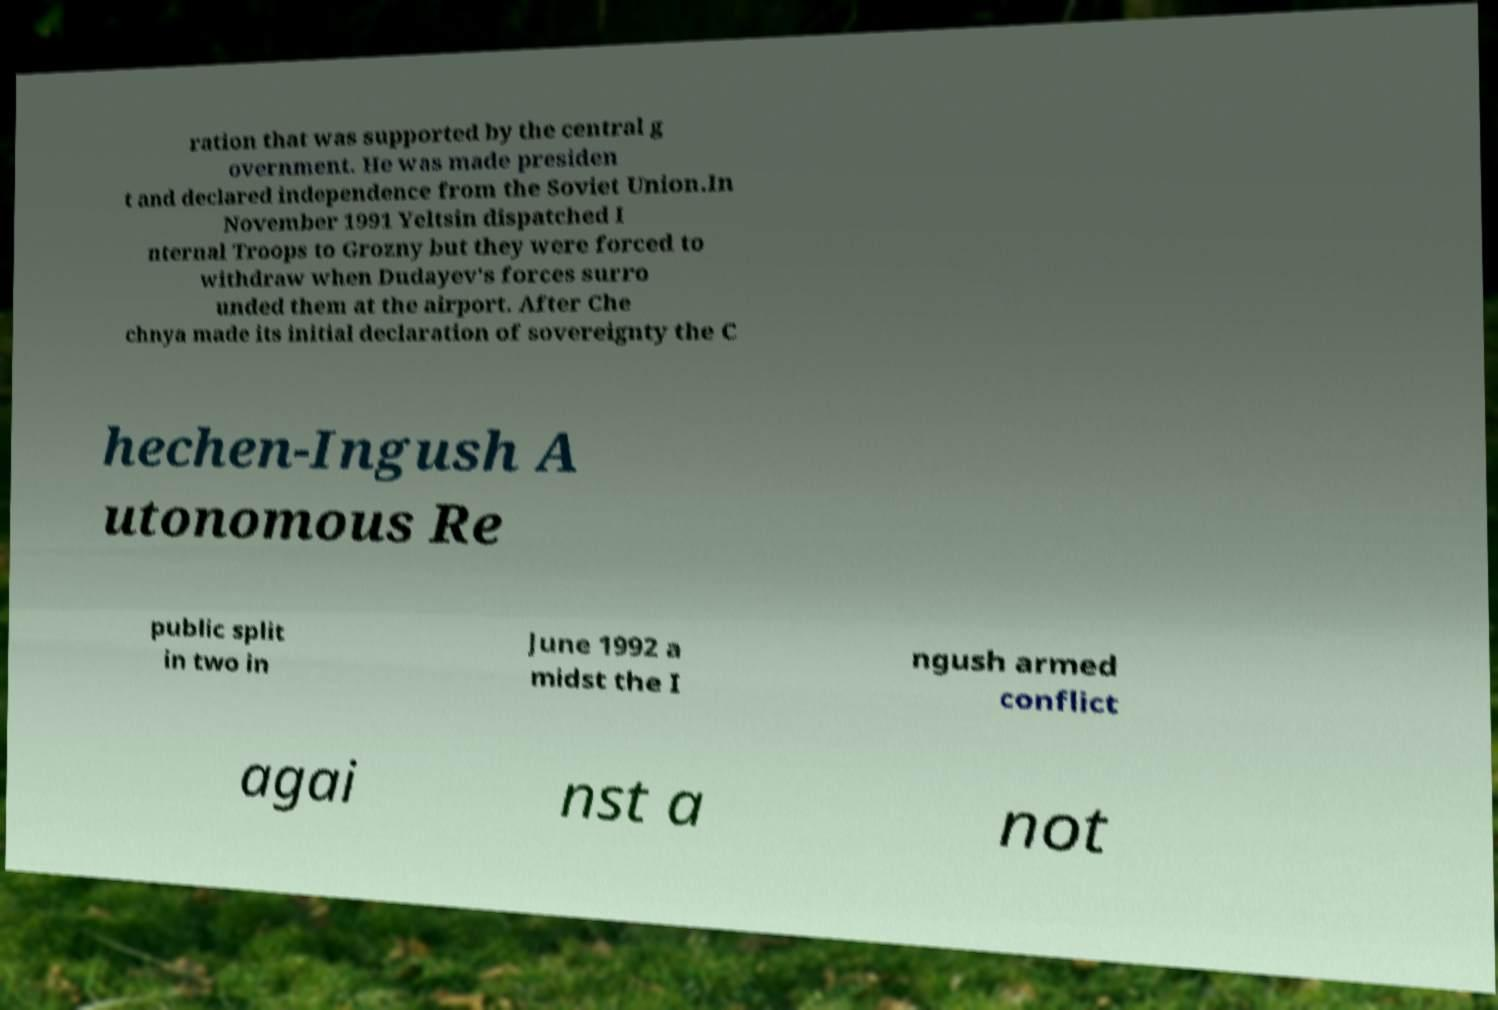Please read and relay the text visible in this image. What does it say? ration that was supported by the central g overnment. He was made presiden t and declared independence from the Soviet Union.In November 1991 Yeltsin dispatched I nternal Troops to Grozny but they were forced to withdraw when Dudayev's forces surro unded them at the airport. After Che chnya made its initial declaration of sovereignty the C hechen-Ingush A utonomous Re public split in two in June 1992 a midst the I ngush armed conflict agai nst a not 